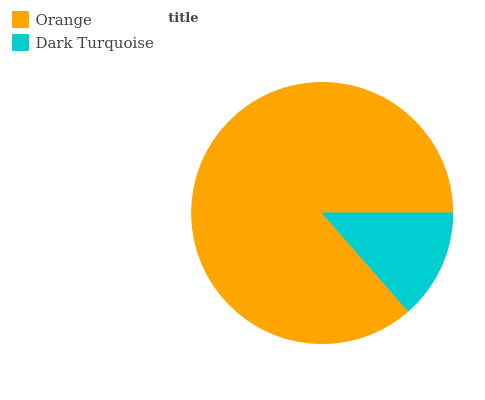Is Dark Turquoise the minimum?
Answer yes or no. Yes. Is Orange the maximum?
Answer yes or no. Yes. Is Dark Turquoise the maximum?
Answer yes or no. No. Is Orange greater than Dark Turquoise?
Answer yes or no. Yes. Is Dark Turquoise less than Orange?
Answer yes or no. Yes. Is Dark Turquoise greater than Orange?
Answer yes or no. No. Is Orange less than Dark Turquoise?
Answer yes or no. No. Is Orange the high median?
Answer yes or no. Yes. Is Dark Turquoise the low median?
Answer yes or no. Yes. Is Dark Turquoise the high median?
Answer yes or no. No. Is Orange the low median?
Answer yes or no. No. 